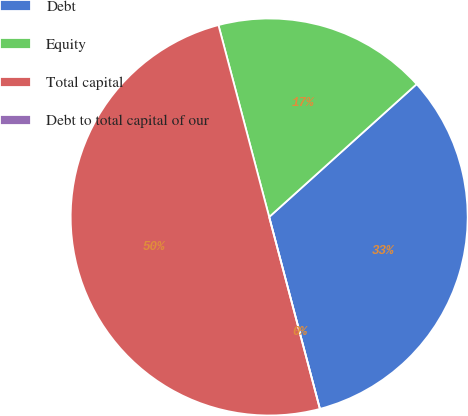Convert chart to OTSL. <chart><loc_0><loc_0><loc_500><loc_500><pie_chart><fcel>Debt<fcel>Equity<fcel>Total capital<fcel>Debt to total capital of our<nl><fcel>32.56%<fcel>17.44%<fcel>50.0%<fcel>0.0%<nl></chart> 